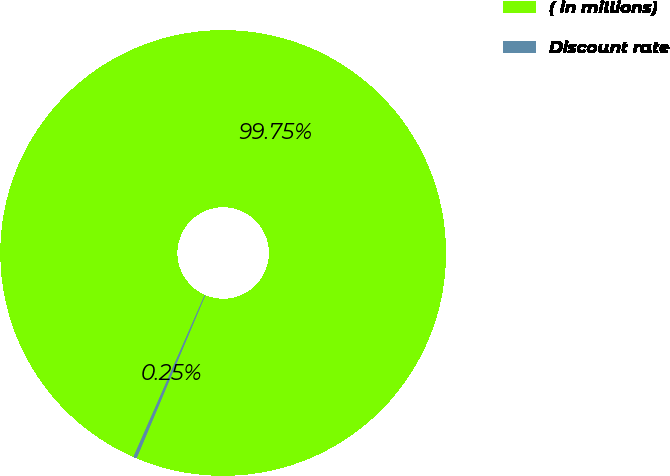Convert chart. <chart><loc_0><loc_0><loc_500><loc_500><pie_chart><fcel>( in millions)<fcel>Discount rate<nl><fcel>99.75%<fcel>0.25%<nl></chart> 